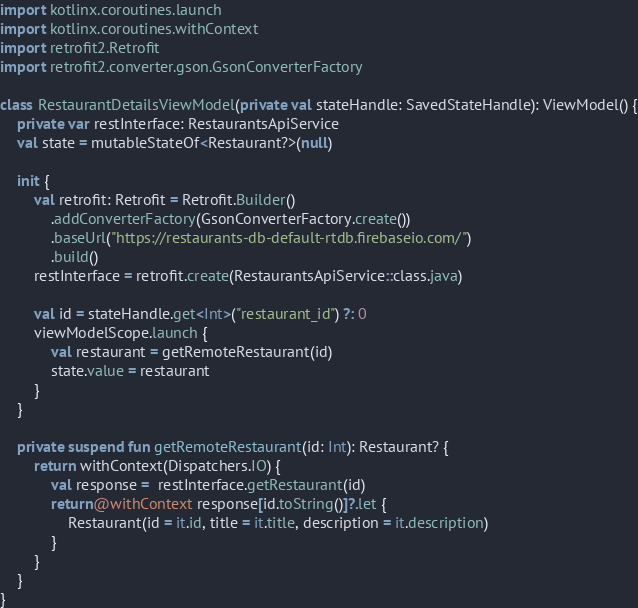<code> <loc_0><loc_0><loc_500><loc_500><_Kotlin_>import kotlinx.coroutines.launch
import kotlinx.coroutines.withContext
import retrofit2.Retrofit
import retrofit2.converter.gson.GsonConverterFactory

class RestaurantDetailsViewModel(private val stateHandle: SavedStateHandle): ViewModel() {
    private var restInterface: RestaurantsApiService
    val state = mutableStateOf<Restaurant?>(null)

    init {
        val retrofit: Retrofit = Retrofit.Builder()
            .addConverterFactory(GsonConverterFactory.create())
            .baseUrl("https://restaurants-db-default-rtdb.firebaseio.com/")
            .build()
        restInterface = retrofit.create(RestaurantsApiService::class.java)

        val id = stateHandle.get<Int>("restaurant_id") ?: 0
        viewModelScope.launch {
            val restaurant = getRemoteRestaurant(id)
            state.value = restaurant
        }
    }

    private suspend fun getRemoteRestaurant(id: Int): Restaurant? {
        return withContext(Dispatchers.IO) {
            val response =  restInterface.getRestaurant(id)
            return@withContext response[id.toString()]?.let {
                Restaurant(id = it.id, title = it.title, description = it.description)
            }
        }
    }
}</code> 